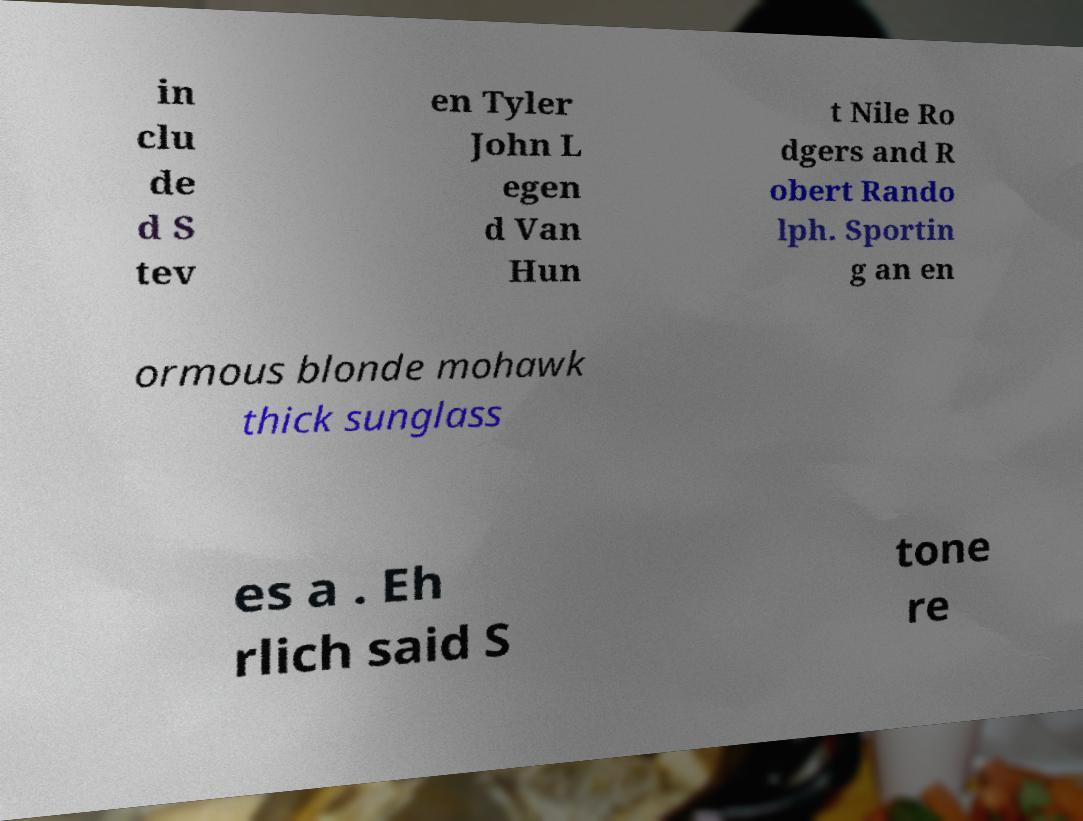What messages or text are displayed in this image? I need them in a readable, typed format. in clu de d S tev en Tyler John L egen d Van Hun t Nile Ro dgers and R obert Rando lph. Sportin g an en ormous blonde mohawk thick sunglass es a . Eh rlich said S tone re 